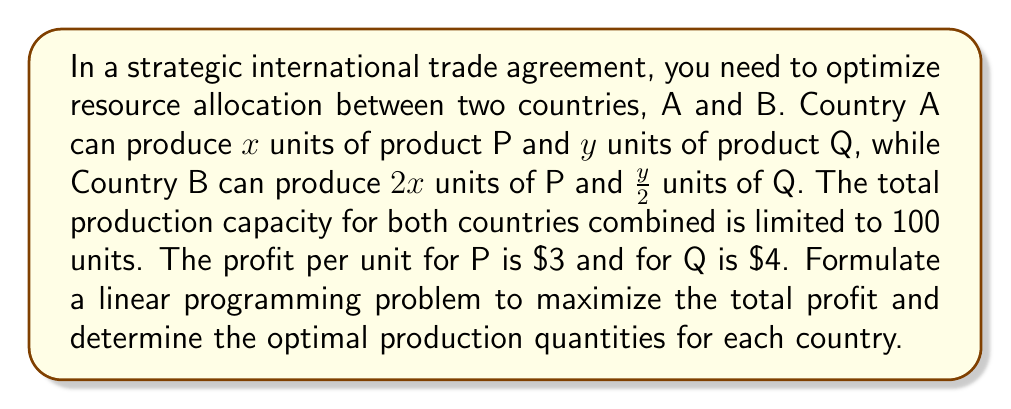What is the answer to this math problem? To solve this problem, we'll follow these steps:

1. Define variables:
   Let $x_A$ and $y_A$ be the units of P and Q produced by Country A
   Let $x_B$ and $y_B$ be the units of P and Q produced by Country B

2. Set up the objective function:
   Maximize profit: $Z = 3(x_A + x_B) + 4(y_A + y_B)$

3. Establish constraints:
   a) Production capacity for Country A: $x_A + y_A \leq 100$
   b) Production capacity for Country B: $2x_B + \frac{1}{2}y_B \leq 100$
   c) Total production limit: $x_A + y_A + x_B + y_B \leq 100$
   d) Non-negativity: $x_A, y_A, x_B, y_B \geq 0$

4. Simplify the problem:
   Due to the production ratios, we can substitute $x_B = \frac{1}{2}x_A$ and $y_B = 2y_A$

5. Rewrite the objective function:
   $Z = 3(x_A + \frac{1}{2}x_A) + 4(y_A + 2y_A) = \frac{9}{2}x_A + 12y_A$

6. Simplify constraints:
   a) $x_A + y_A \leq 100$
   b) $x_A + y_A \leq 100$ (simplified from $2(\frac{1}{2}x_A) + \frac{1}{2}(2y_A) \leq 100$)
   c) $x_A + y_A + \frac{1}{2}x_A + 2y_A \leq 100$, which simplifies to $\frac{3}{2}x_A + 3y_A \leq 100$

7. Solve using the simplex method or graphical method:
   The optimal solution is at the intersection of constraints (a) and (c):
   $x_A + y_A = 100$ and $\frac{3}{2}x_A + 3y_A = 100$

   Solving these equations:
   $x_A = 60$ and $y_A = 40$

8. Calculate $x_B$ and $y_B$:
   $x_B = \frac{1}{2}x_A = 30$
   $y_B = 2y_A = 80$

9. Verify the total production constraint:
   $60 + 40 + 30 + 80 = 210$, which exceeds the limit of 100

10. Adjust the solution to meet the total production constraint:
    Scale down the production by a factor of $\frac{100}{210}$

    Country A: $x_A = 60 \times \frac{100}{210} \approx 28.57$, $y_A = 40 \times \frac{100}{210} \approx 19.05$
    Country B: $x_B = 30 \times \frac{100}{210} \approx 14.29$, $y_B = 80 \times \frac{100}{210} \approx 38.10$

11. Calculate the maximum profit:
    $Z = 3(28.57 + 14.29) + 4(19.05 + 38.10) \approx 371.43$
Answer: Country A: P ≈ 28.57, Q ≈ 19.05; Country B: P ≈ 14.29, Q ≈ 38.10; Max profit ≈ $371.43 